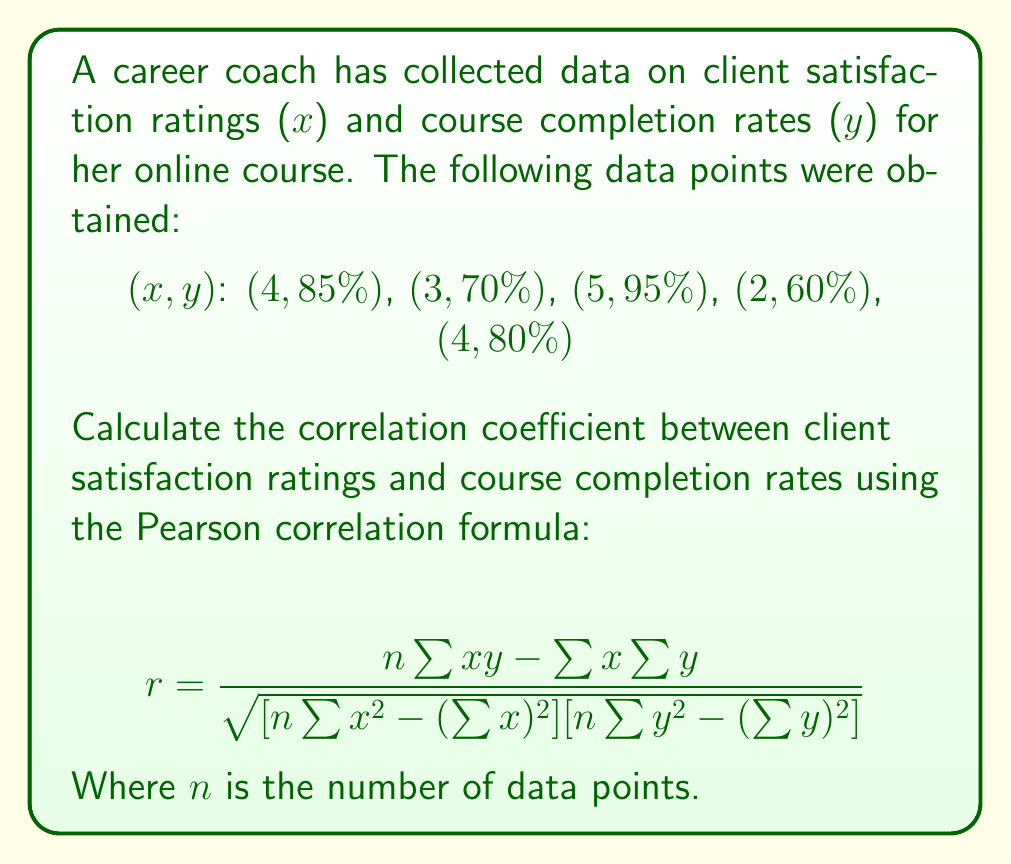What is the answer to this math problem? Let's follow these steps to calculate the correlation coefficient:

1. Calculate the required sums:
   $n = 5$
   $\sum x = 4 + 3 + 5 + 2 + 4 = 18$
   $\sum y = 0.85 + 0.70 + 0.95 + 0.60 + 0.80 = 3.90$
   $\sum xy = (4 \times 0.85) + (3 \times 0.70) + (5 \times 0.95) + (2 \times 0.60) + (4 \times 0.80) = 15.35$
   $\sum x^2 = 4^2 + 3^2 + 5^2 + 2^2 + 4^2 = 70$
   $\sum y^2 = 0.85^2 + 0.70^2 + 0.95^2 + 0.60^2 + 0.80^2 = 3.095$

2. Apply the Pearson correlation formula:

   $$ r = \frac{5(15.35) - (18)(3.90)}{\sqrt{[5(70) - (18)^2][5(3.095) - (3.90)^2]}} $$

3. Simplify:
   $$ r = \frac{76.75 - 70.20}{\sqrt{(350 - 324)(15.475 - 15.21)}} $$
   $$ r = \frac{6.55}{\sqrt{(26)(0.265)}} $$
   $$ r = \frac{6.55}{\sqrt{6.89}} $$
   $$ r = \frac{6.55}{2.625} $$

4. Calculate the final result:
   $$ r \approx 0.9714 $$
Answer: $0.9714$ 